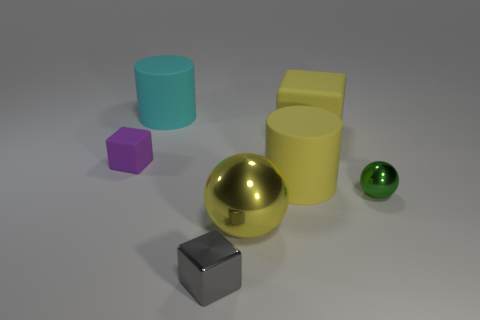Are there any yellow cylinders that have the same size as the yellow shiny ball?
Give a very brief answer. Yes. What material is the tiny object behind the tiny green shiny object?
Offer a terse response. Rubber. Is the material of the large cyan object behind the shiny block the same as the green sphere?
Keep it short and to the point. No. There is a matte object that is the same size as the green metallic thing; what shape is it?
Offer a terse response. Cube. What number of big cylinders are the same color as the large metal ball?
Provide a short and direct response. 1. Is the number of big cyan cylinders that are on the right side of the small metal ball less than the number of cubes on the left side of the cyan thing?
Ensure brevity in your answer.  Yes. Are there any large rubber cylinders in front of the cyan cylinder?
Provide a succinct answer. Yes. There is a sphere that is right of the matte block that is behind the purple matte thing; are there any balls in front of it?
Ensure brevity in your answer.  Yes. There is a big yellow matte object in front of the purple matte cube; does it have the same shape as the cyan object?
Keep it short and to the point. Yes. The big ball that is the same material as the green object is what color?
Offer a terse response. Yellow. 